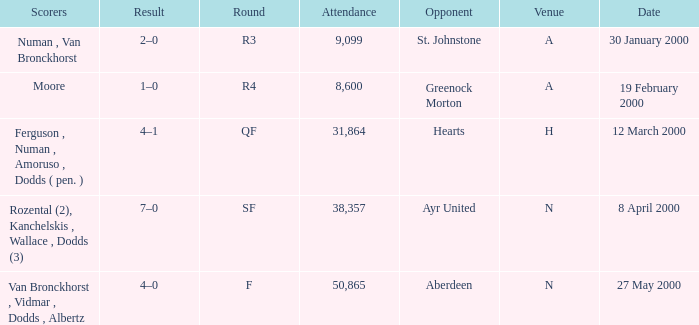Who was on 12 March 2000? Ferguson , Numan , Amoruso , Dodds ( pen. ). 